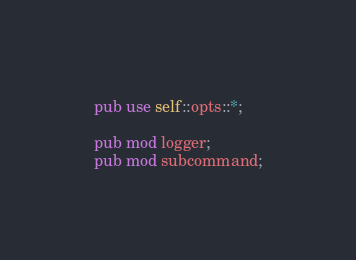Convert code to text. <code><loc_0><loc_0><loc_500><loc_500><_Rust_>pub use self::opts::*;

pub mod logger;
pub mod subcommand;
</code> 